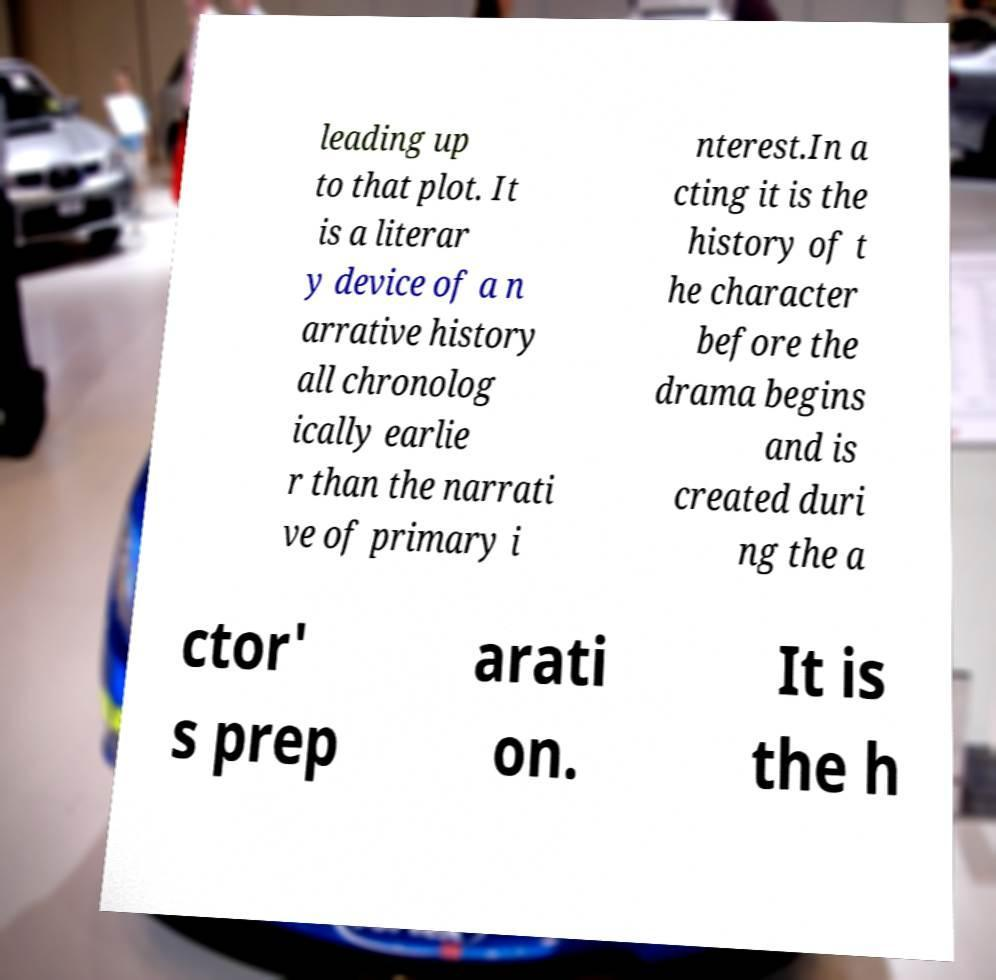Could you assist in decoding the text presented in this image and type it out clearly? leading up to that plot. It is a literar y device of a n arrative history all chronolog ically earlie r than the narrati ve of primary i nterest.In a cting it is the history of t he character before the drama begins and is created duri ng the a ctor' s prep arati on. It is the h 